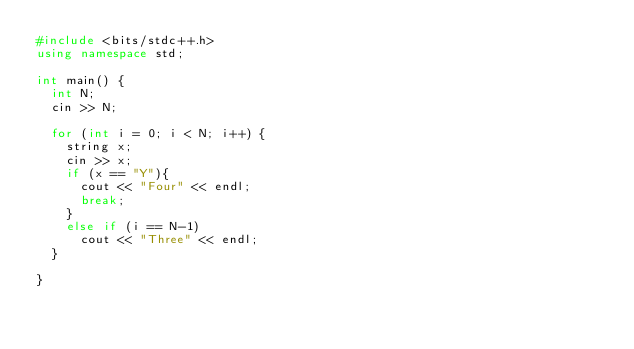Convert code to text. <code><loc_0><loc_0><loc_500><loc_500><_C++_>#include <bits/stdc++.h>
using namespace std;

int main() {
  int N;
  cin >> N;

  for (int i = 0; i < N; i++) {
    string x;
    cin >> x;
    if (x == "Y"){
      cout << "Four" << endl;
      break;
    }
    else if (i == N-1)
      cout << "Three" << endl;
  }

}
</code> 